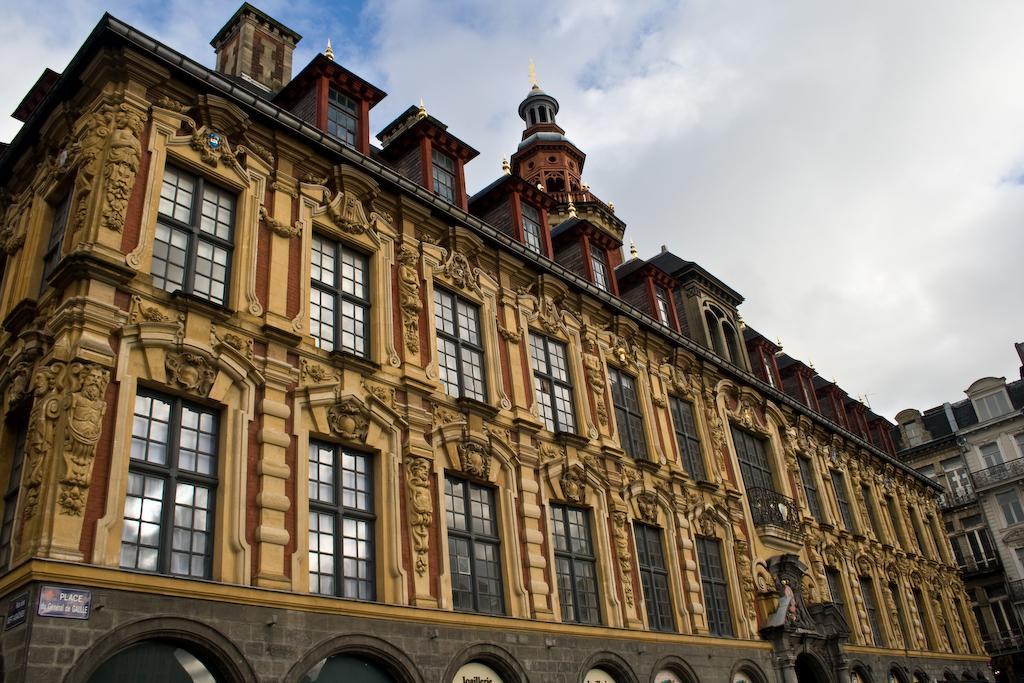Describe this image in one or two sentences. In this image, we can see buildings. There are clouds in the sky. 